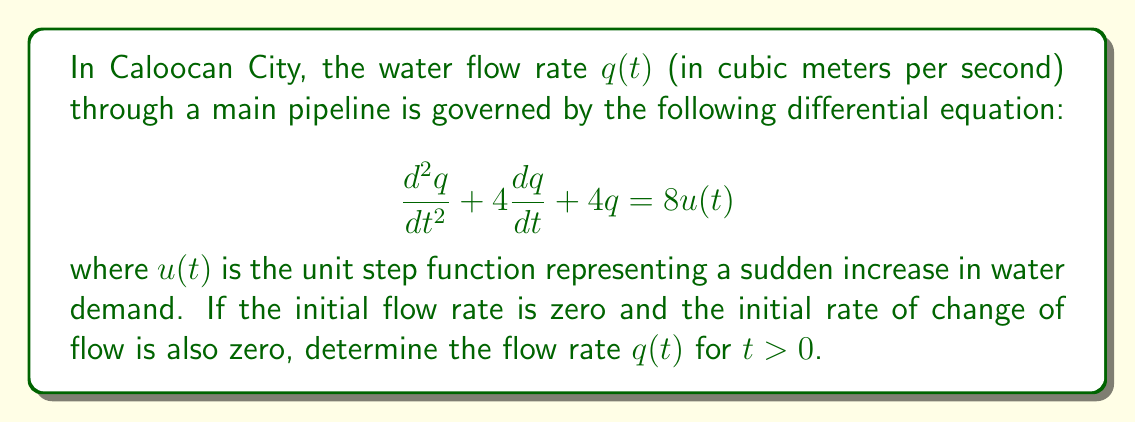Help me with this question. To solve this problem, we'll use the Laplace transform method:

1) First, let's take the Laplace transform of both sides of the equation:

   $\mathcal{L}\{\frac{d^2q}{dt^2} + 4\frac{dq}{dt} + 4q\} = \mathcal{L}\{8u(t)\}$

2) Using Laplace transform properties:

   $s^2Q(s) - sq(0) - q'(0) + 4[sQ(s) - q(0)] + 4Q(s) = \frac{8}{s}$

   Where $Q(s) = \mathcal{L}\{q(t)\}$

3) Given initial conditions $q(0) = 0$ and $q'(0) = 0$, we simplify:

   $s^2Q(s) + 4sQ(s) + 4Q(s) = \frac{8}{s}$

4) Factor out $Q(s)$:

   $Q(s)(s^2 + 4s + 4) = \frac{8}{s}$

5) Solve for $Q(s)$:

   $Q(s) = \frac{8}{s(s^2 + 4s + 4)} = \frac{8}{s(s + 2)^2}$

6) Perform partial fraction decomposition:

   $Q(s) = \frac{A}{s} + \frac{B}{(s+2)} + \frac{C}{(s+2)^2}$

   Solving for A, B, and C:

   $A = 2$, $B = -4$, $C = 2$

7) Rewrite $Q(s)$:

   $Q(s) = \frac{2}{s} - \frac{4}{s+2} + \frac{2}{(s+2)^2}$

8) Take the inverse Laplace transform:

   $q(t) = \mathcal{L}^{-1}\{Q(s)\} = 2 - 4e^{-2t} + 2te^{-2t}$

This gives us the flow rate $q(t)$ for $t > 0$.
Answer: $q(t) = 2 - 4e^{-2t} + 2te^{-2t}$ for $t > 0$ 